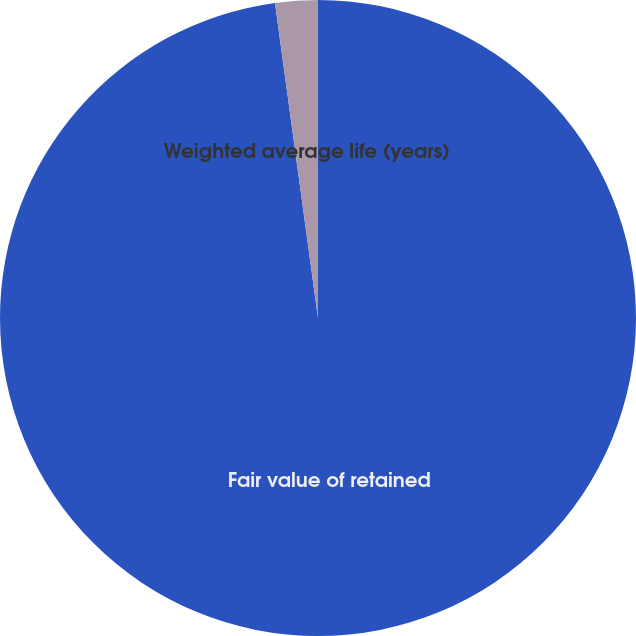Convert chart. <chart><loc_0><loc_0><loc_500><loc_500><pie_chart><fcel>Fair value of retained<fcel>Weighted average life (years)<nl><fcel>97.84%<fcel>2.16%<nl></chart> 